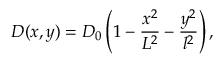<formula> <loc_0><loc_0><loc_500><loc_500>D ( x , y ) = D _ { 0 } \left ( 1 - \frac { x ^ { 2 } } { L ^ { 2 } } - \frac { y ^ { 2 } } { l ^ { 2 } } \right ) ,</formula> 